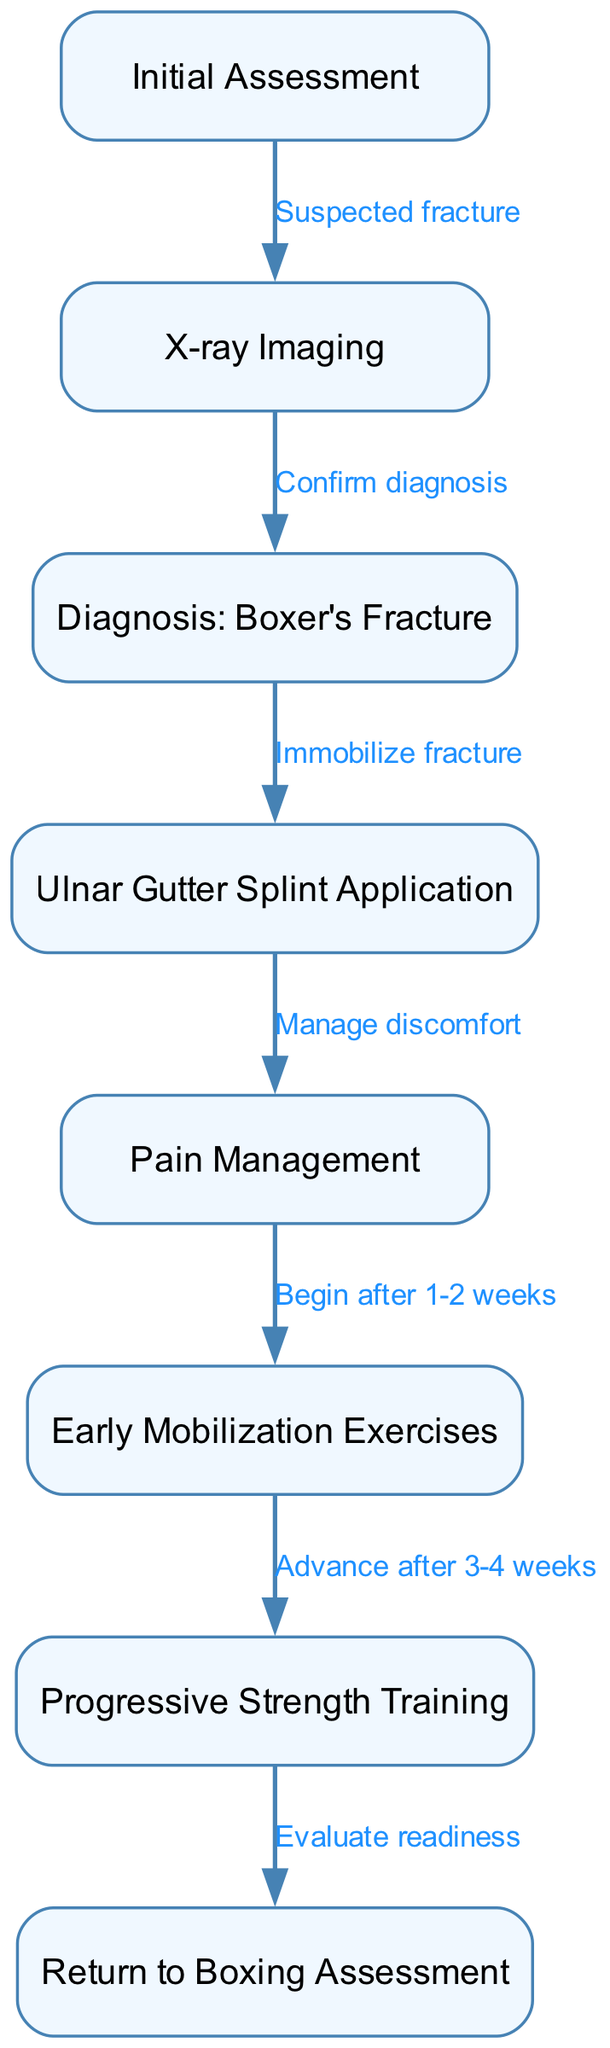What is the first step in the clinical pathway? The first step is "Initial Assessment," which is represented as node 1 in the diagram.
Answer: Initial Assessment How many nodes are present in the clinical pathway? The diagram includes 8 nodes in total, each representing a specific aspect of the clinical management for boxer's fracture.
Answer: 8 What is the diagnosis confirmed by the X-ray Imaging step? The diagnosis confirmed after the X-ray imaging step is "Boxer's Fracture," indicated in node 3.
Answer: Boxer's Fracture What technique is applied after diagnosing a boxer's fracture? Following the diagnosis, the technique applied is "Ulnar Gutter Splint Application," which is node 4.
Answer: Ulnar Gutter Splint Application When should early mobilization exercises begin? Early mobilization exercises should begin after 1-2 weeks of injury, as indicated by the edge from node 5 to node 6.
Answer: After 1-2 weeks What is the relationship between pain management and early mobilization exercises? Pain management (node 5) is an action taken before early mobilization exercises (node 6) can begin, as indicated by the flow from node 5 to node 6.
Answer: Pain management precedes early mobilization exercises At what stage should progressive strength training be advanced? Progressive strength training should be advanced after 3-4 weeks, as specified by the edge from node 6 to node 7.
Answer: After 3-4 weeks What is evaluated before returning to boxing? "Return to Boxing Assessment," which is represented as node 8, evaluates the readiness for a boxer to return to their sport.
Answer: Return to Boxing Assessment What does node 4 signify in the context of managing a boxer's fracture? Node 4 signifies the "Ulnar Gutter Splint Application," a technique used for immobilizing the fracture post-diagnosis.
Answer: Ulnar Gutter Splint Application 